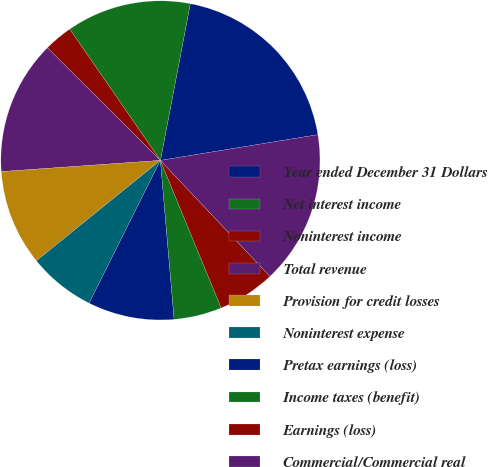Convert chart. <chart><loc_0><loc_0><loc_500><loc_500><pie_chart><fcel>Year ended December 31 Dollars<fcel>Net interest income<fcel>Noninterest income<fcel>Total revenue<fcel>Provision for credit losses<fcel>Noninterest expense<fcel>Pretax earnings (loss)<fcel>Income taxes (benefit)<fcel>Earnings (loss)<fcel>Commercial/Commercial real<nl><fcel>19.42%<fcel>12.62%<fcel>2.91%<fcel>13.59%<fcel>9.71%<fcel>6.8%<fcel>8.74%<fcel>4.85%<fcel>5.83%<fcel>15.53%<nl></chart> 